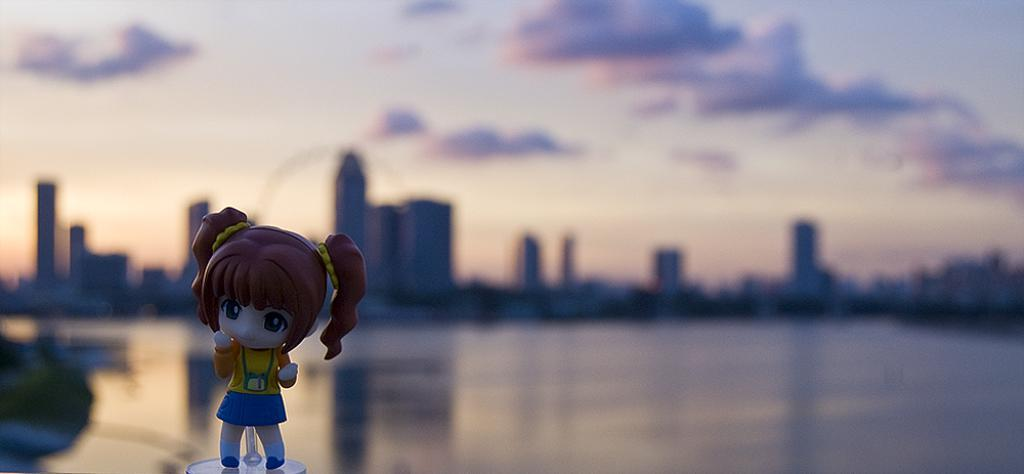What is the main subject of the image? There is a doll of a girl in the image. What can be seen in the background of the image? There is a lake and buildings in the background of the image. What is visible at the top of the image? The sky is visible at the top of the image. What can be observed in the sky? There are clouds in the sky. What type of boot is the girl wearing in the image? The image does not show the girl wearing any boots; it only features a doll of a girl. Can you tell me what the doctor is doing in the image? There is no doctor present in the image; it only features a doll of a girl. 